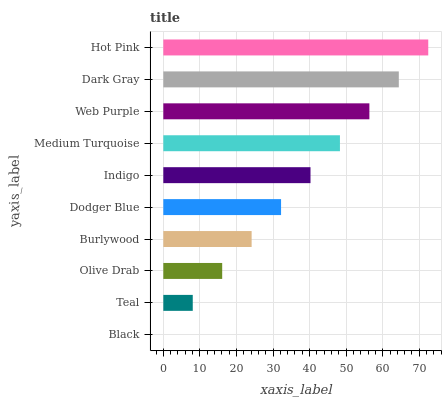Is Black the minimum?
Answer yes or no. Yes. Is Hot Pink the maximum?
Answer yes or no. Yes. Is Teal the minimum?
Answer yes or no. No. Is Teal the maximum?
Answer yes or no. No. Is Teal greater than Black?
Answer yes or no. Yes. Is Black less than Teal?
Answer yes or no. Yes. Is Black greater than Teal?
Answer yes or no. No. Is Teal less than Black?
Answer yes or no. No. Is Indigo the high median?
Answer yes or no. Yes. Is Dodger Blue the low median?
Answer yes or no. Yes. Is Teal the high median?
Answer yes or no. No. Is Dark Gray the low median?
Answer yes or no. No. 